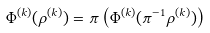<formula> <loc_0><loc_0><loc_500><loc_500>\Phi ^ { ( k ) } ( \rho ^ { ( k ) } ) = \pi \left ( \Phi ^ { ( k ) } ( \pi ^ { - 1 } \rho ^ { ( k ) } ) \right )</formula> 